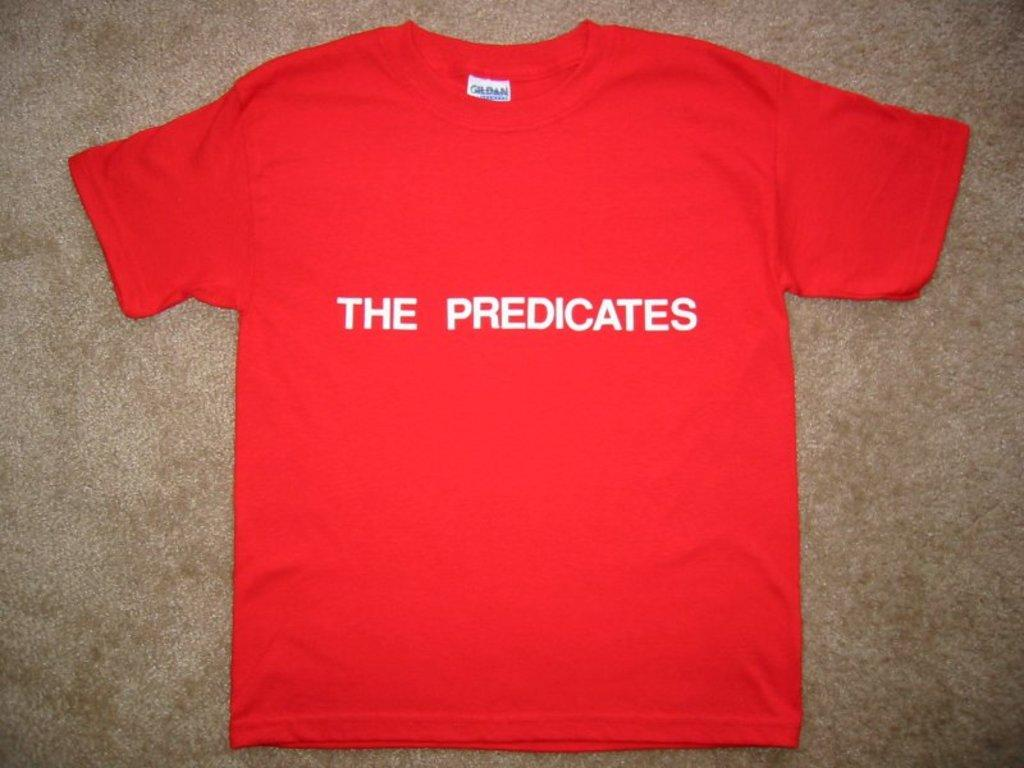What type of clothing item is visible in the image? There is a t-shirt in the image. Where is the t-shirt located in relation to the image? The t-shirt is placed on the ground and located in the center of the image. What type of blood stain can be seen on the t-shirt in the image? There is no blood stain visible on the t-shirt in the image. How is the t-shirt being used as a mode of transport in the image? The t-shirt is not being used as a mode of transport in the image; it is simply placed on the ground. 